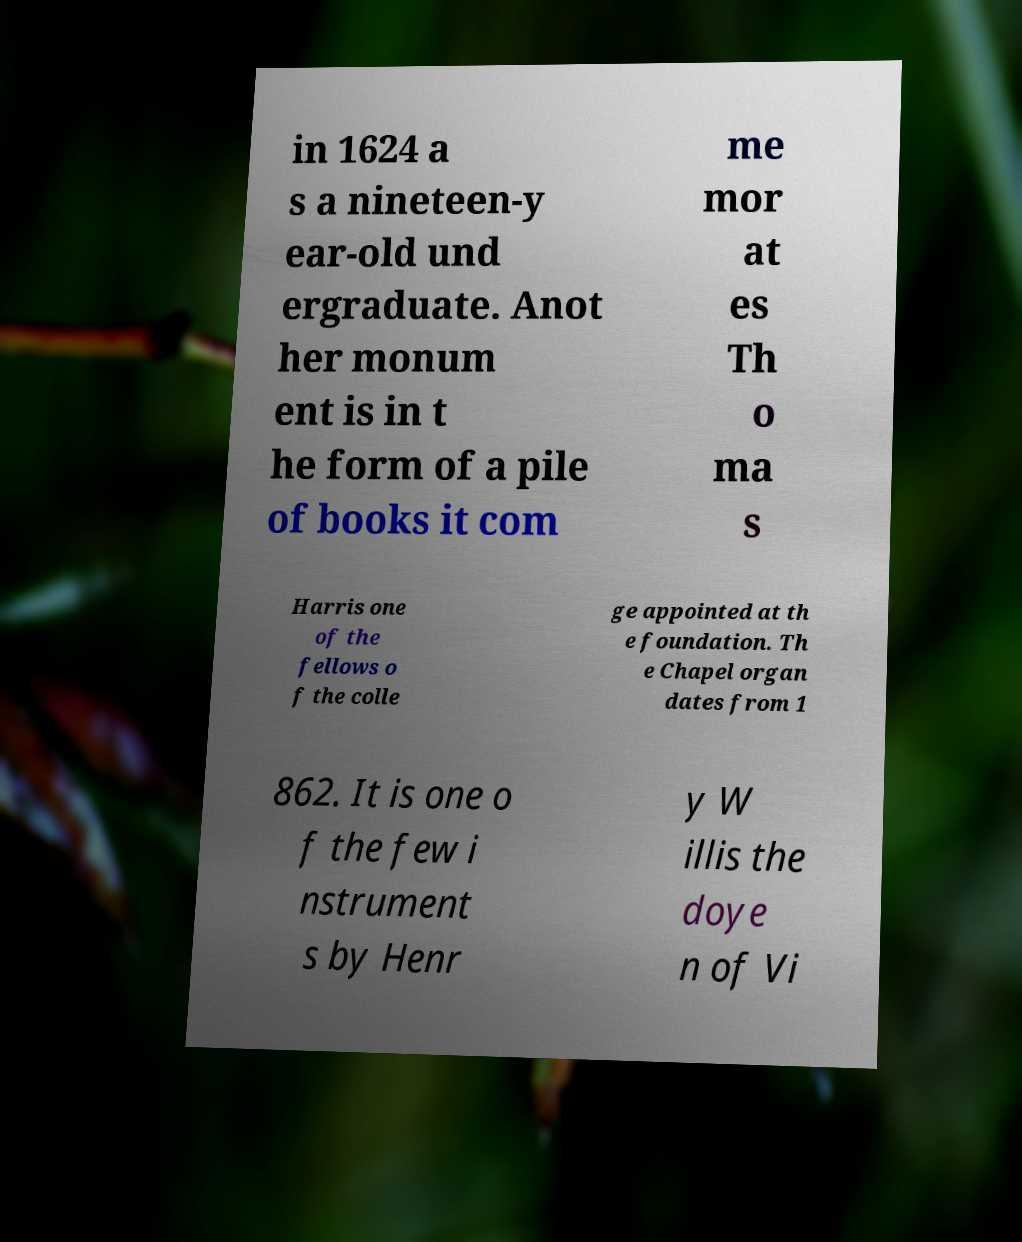Please identify and transcribe the text found in this image. in 1624 a s a nineteen-y ear-old und ergraduate. Anot her monum ent is in t he form of a pile of books it com me mor at es Th o ma s Harris one of the fellows o f the colle ge appointed at th e foundation. Th e Chapel organ dates from 1 862. It is one o f the few i nstrument s by Henr y W illis the doye n of Vi 